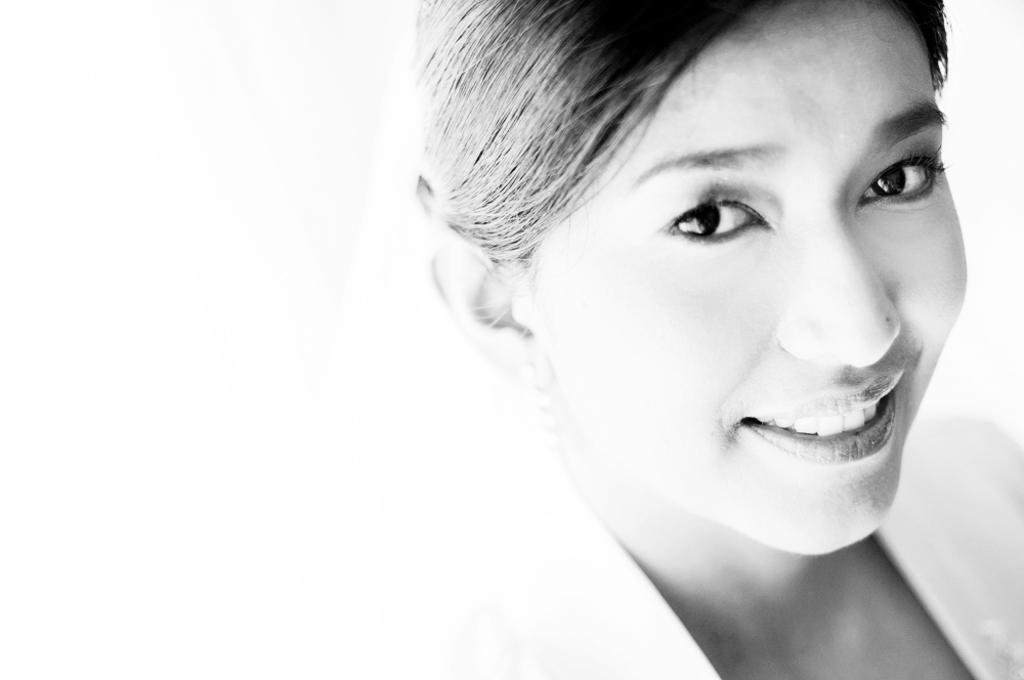What is the color scheme of the image? The image is black and white. Who is present in the image? There is a woman in the image. What is the woman doing in the image? The woman is smiling. What is the woman's position in the image? The provided facts do not give information about the woman's position in the image. --- 